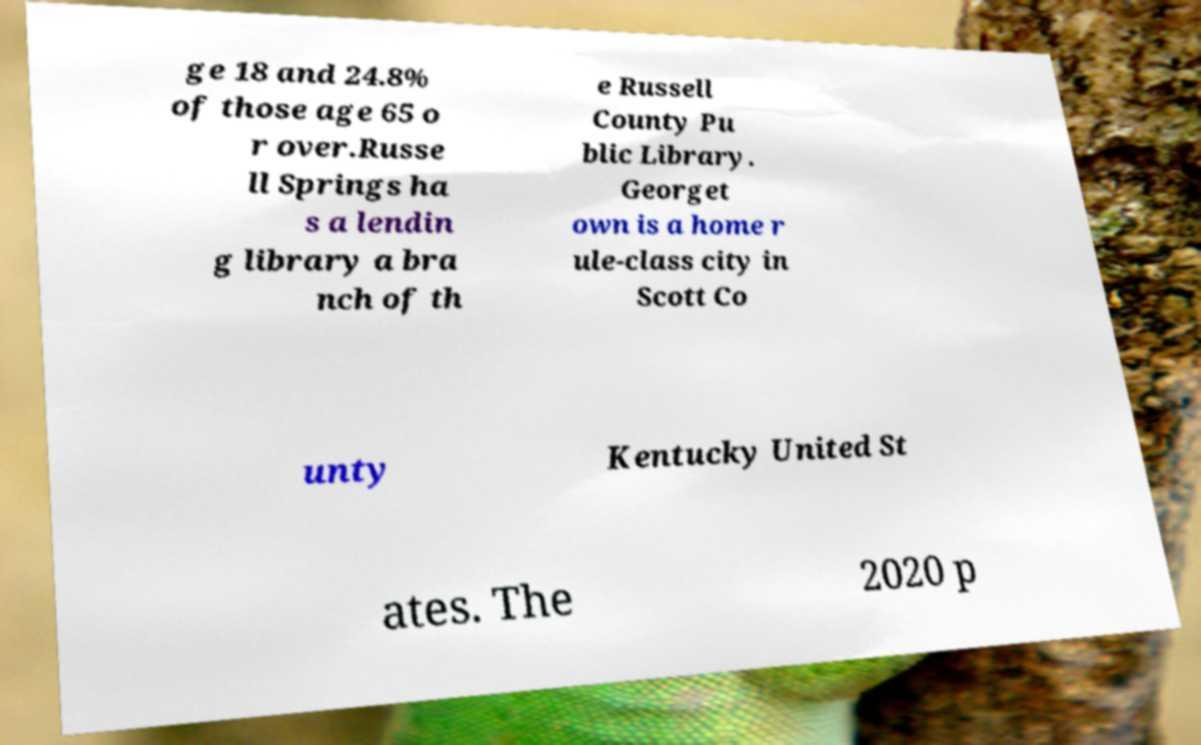Please read and relay the text visible in this image. What does it say? ge 18 and 24.8% of those age 65 o r over.Russe ll Springs ha s a lendin g library a bra nch of th e Russell County Pu blic Library. Georget own is a home r ule-class city in Scott Co unty Kentucky United St ates. The 2020 p 